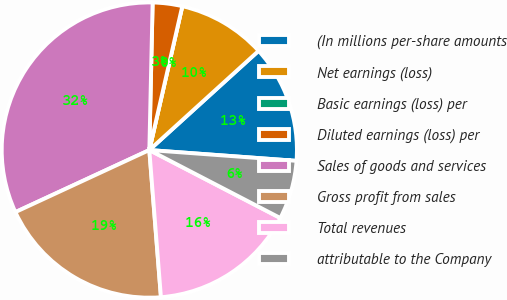Convert chart. <chart><loc_0><loc_0><loc_500><loc_500><pie_chart><fcel>(In millions per-share amounts<fcel>Net earnings (loss)<fcel>Basic earnings (loss) per<fcel>Diluted earnings (loss) per<fcel>Sales of goods and services<fcel>Gross profit from sales<fcel>Total revenues<fcel>attributable to the Company<nl><fcel>12.9%<fcel>9.68%<fcel>0.0%<fcel>3.23%<fcel>32.26%<fcel>19.35%<fcel>16.13%<fcel>6.45%<nl></chart> 